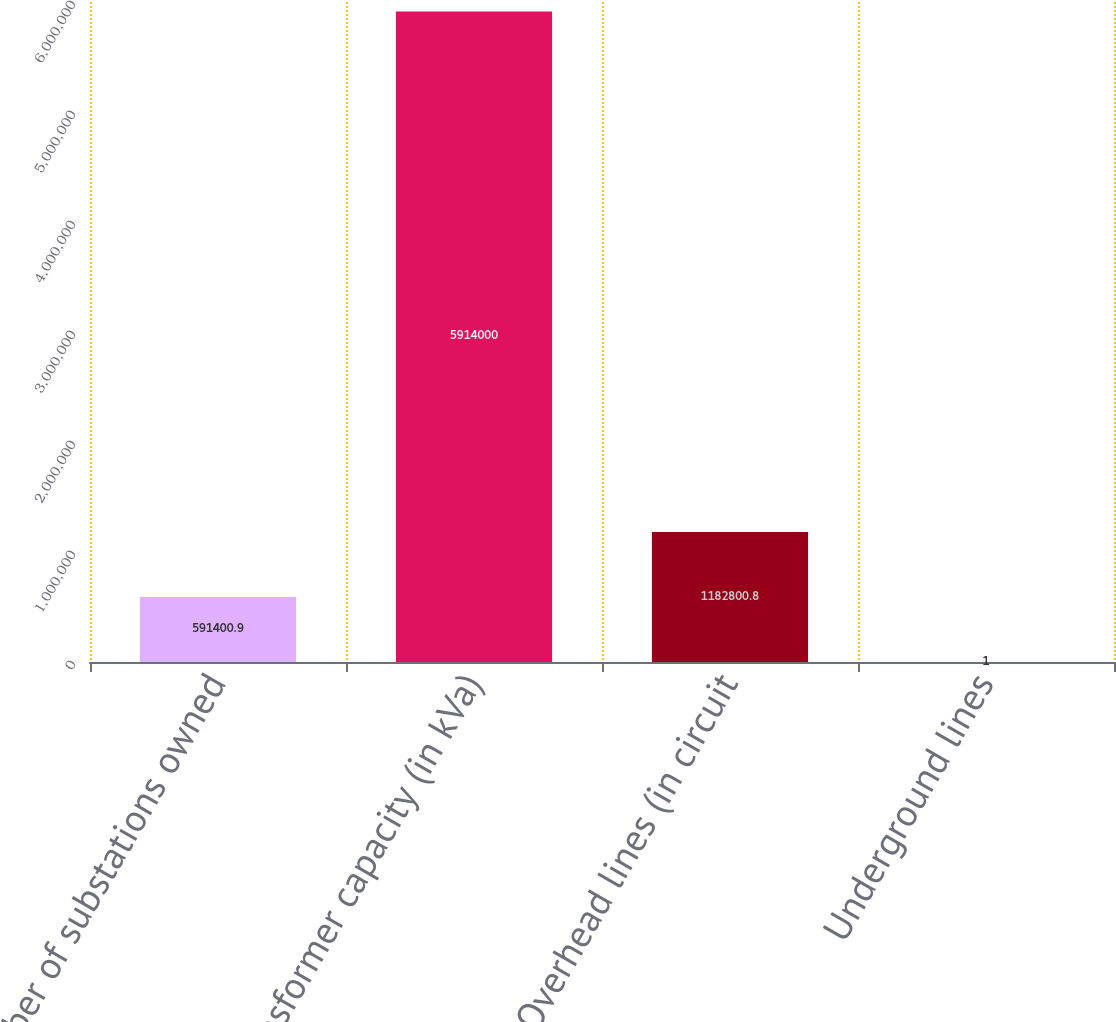Convert chart. <chart><loc_0><loc_0><loc_500><loc_500><bar_chart><fcel>Number of substations owned<fcel>Transformer capacity (in kVa)<fcel>Overhead lines (in circuit<fcel>Underground lines<nl><fcel>591401<fcel>5.914e+06<fcel>1.1828e+06<fcel>1<nl></chart> 